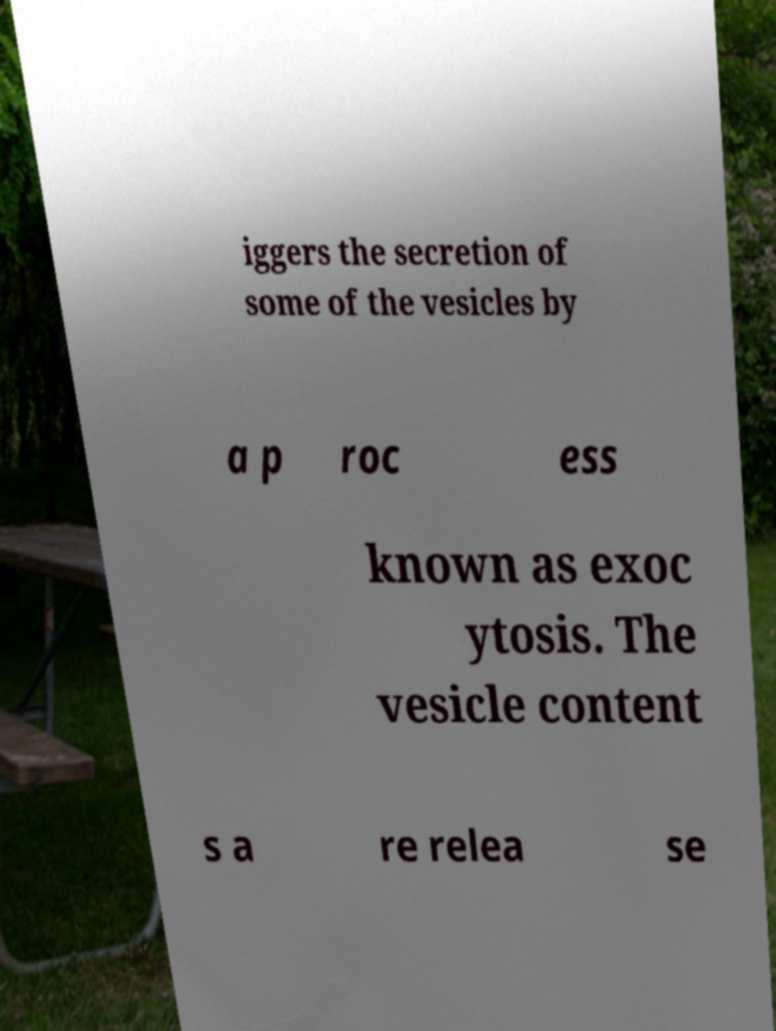Can you read and provide the text displayed in the image?This photo seems to have some interesting text. Can you extract and type it out for me? iggers the secretion of some of the vesicles by a p roc ess known as exoc ytosis. The vesicle content s a re relea se 